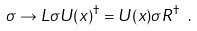<formula> <loc_0><loc_0><loc_500><loc_500>\sigma \to L \sigma U ( x ) ^ { \dagger } = U ( x ) \sigma R ^ { \dagger } \ .</formula> 